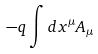<formula> <loc_0><loc_0><loc_500><loc_500>- q \int d x ^ { \mu } A _ { \mu }</formula> 